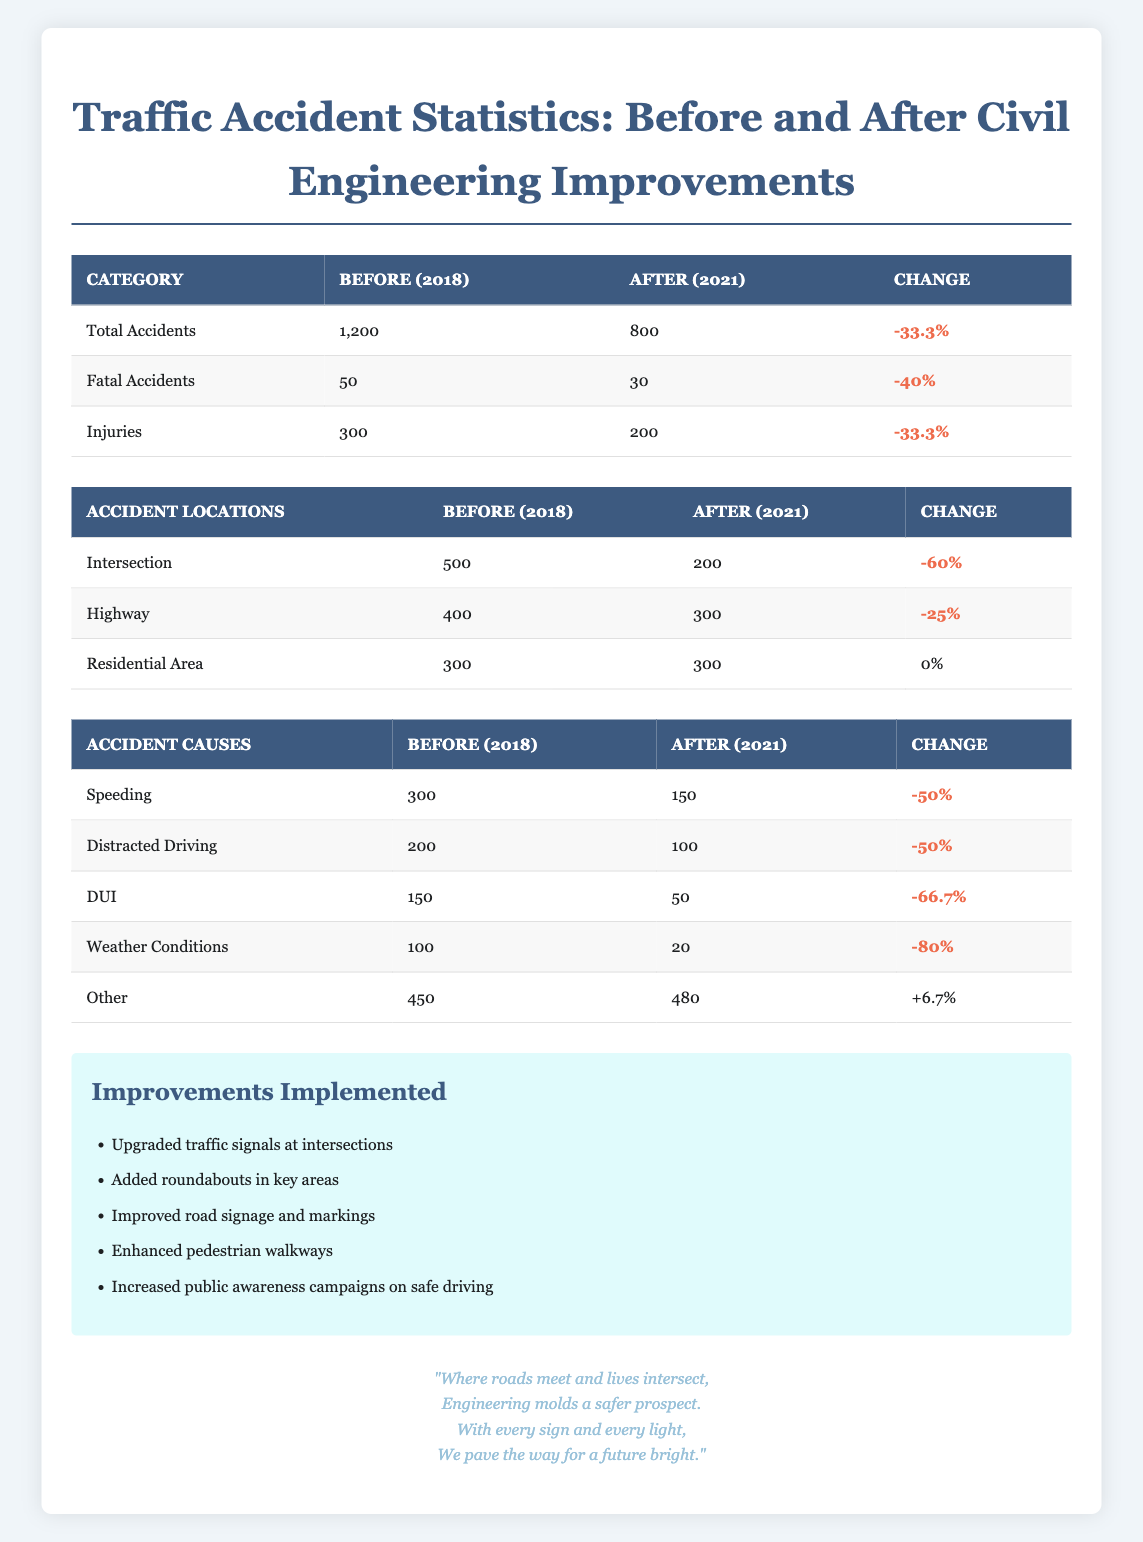What was the total number of accidents in 2018? The table states that the total accidents before improvements in 2018 were 1200.
Answer: 1200 What percentage reduction in total accidents occurred after the civil engineering improvements? To find the percentage reduction, use the formula: ((Initial value - Final value) / Initial value) * 100. Here, it is ((1200 - 800) / 1200) * 100 = 33.3%.
Answer: 33.3% Was there an increase in the number of "Other" accidents from 2018 to 2021? The table shows that the number of "Other" accidents was 450 in 2018 and increased to 480 in 2021. Thus, there was an increase.
Answer: Yes What was the total reduction in fatal accidents from 2018 to 2021? The number of fatal accidents decreased from 50 in 2018 to 30 in 2021. Thus, the total reduction is 50 - 30 = 20 fatal accidents.
Answer: 20 Which location had the greatest percentage decrease in accidents after the improvements? For intersections, the decrease was from 500 to 200, which is a percentage change of 60%. For highways, it decreased from 400 to 300, a 25% change. The location with the greatest percentage decrease is intersections at 60%.
Answer: Intersections How many accidents occurred in the highway category after improvements? According to the table, the number of accidents in the highway category after improvements in 2021 is 300.
Answer: 300 What was the total number of injuries before improvements? The table indicates that the total number of injuries before improvements in 2018 was 300.
Answer: 300 How many fewer injuries were reported in 2021 compared to 2018? The total number of injuries in 2018 was 300, while in 2021 it was 200. Therefore, the difference is 300 - 200 = 100 fewer injuries reported.
Answer: 100 Did the civil engineering improvements make a significant impact on reducing weather-related accidents? Yes, weather-related accidents decreased from 100 to 20, which is a significant reduction of 80%.
Answer: Yes 